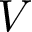Convert formula to latex. <formula><loc_0><loc_0><loc_500><loc_500>V</formula> 